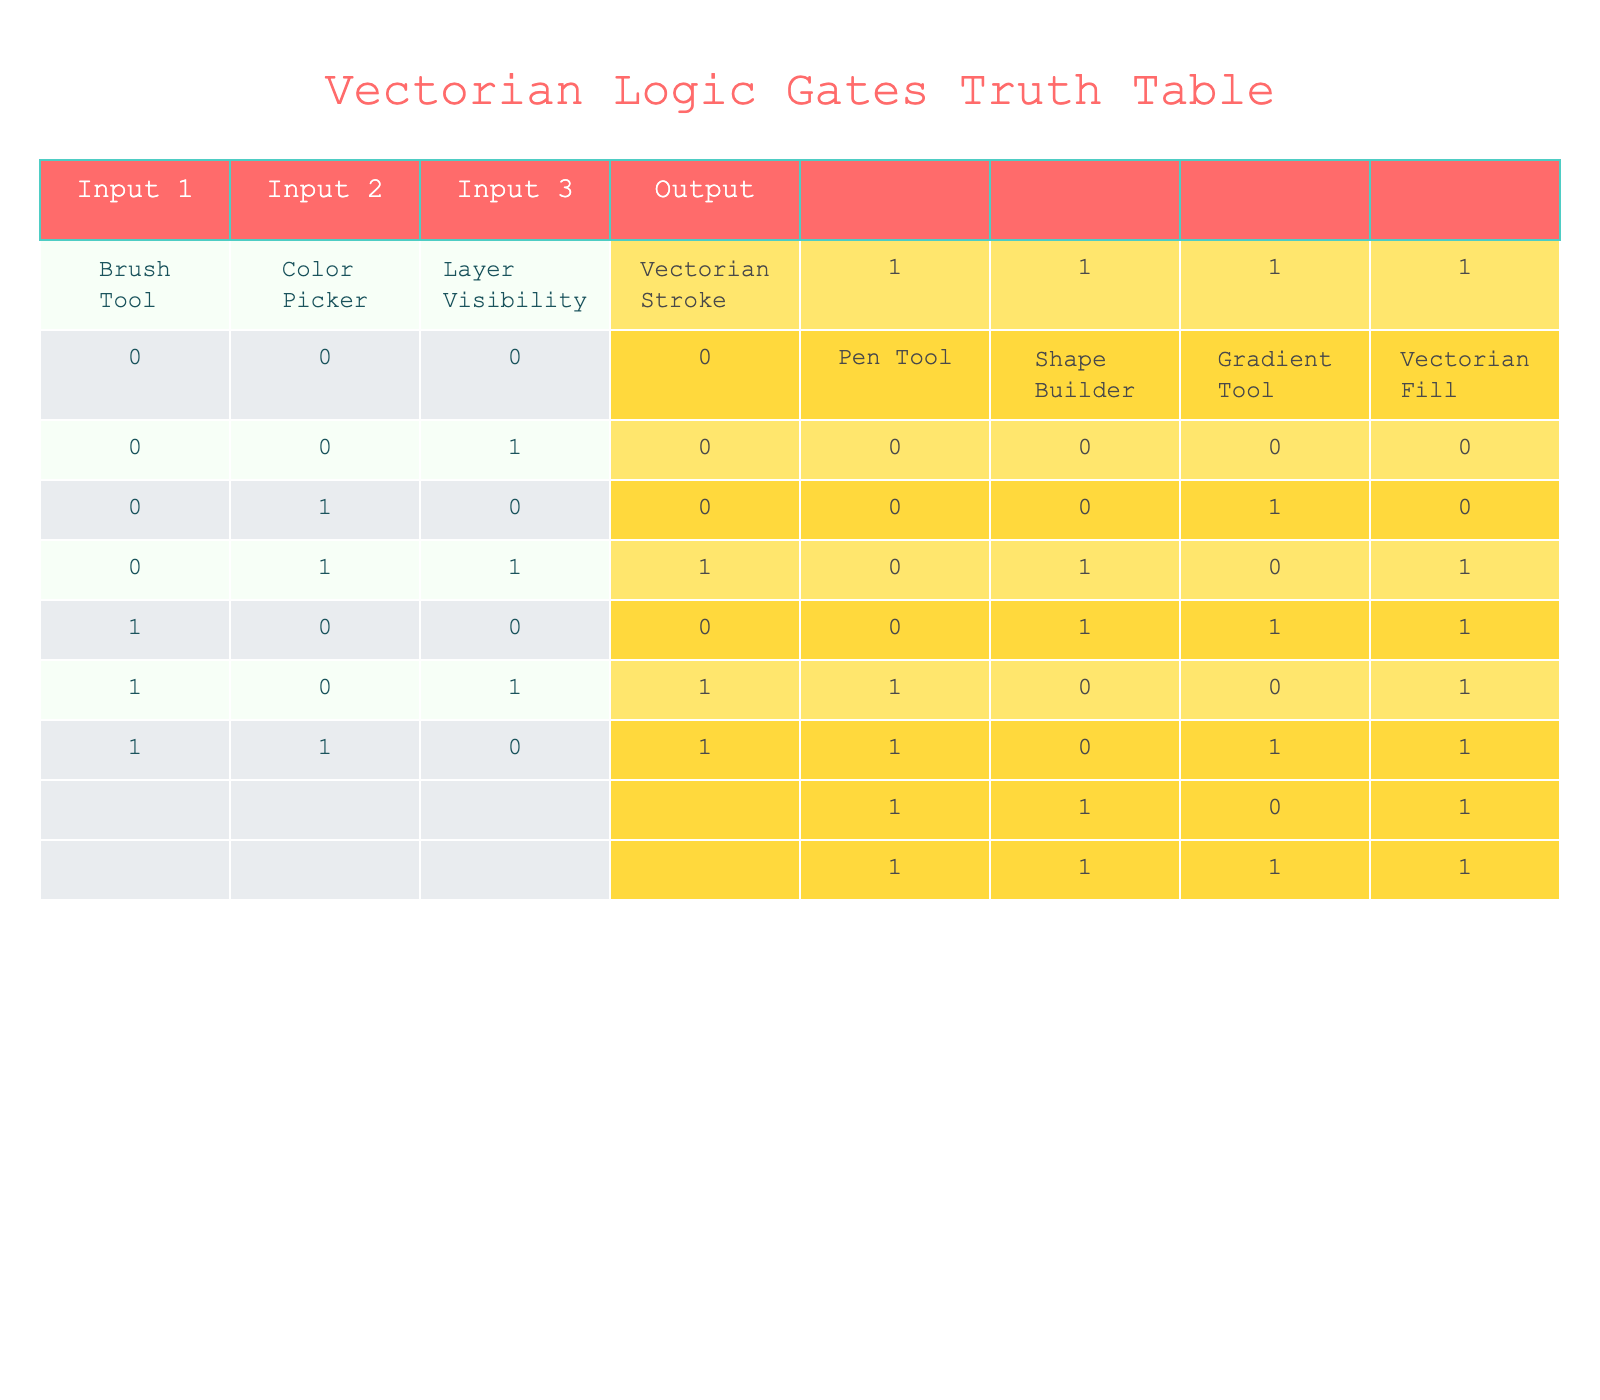What is the output when the Brush Tool and Color Picker are both off? According to the table, when both the Brush Tool (0) and Color Picker (0) are off, the output is 0, indicating no Vectorian Stroke is produced.
Answer: 0 What happens to the output if the Pen Tool is on while the Shape Builder and Gradient Tool are both off? In the table, when the Pen Tool is on (1) and the Shape Builder and Gradient Tool are both off (0, 0), the output for Vectorian Fill is 1.
Answer: 1 How many combinations of inputs result in a Vectorian Stroke output of 1? The table indicates that there are 4 combinations of inputs that result in a Vectorian Stroke output of 1: (0, 1, 1), (1, 0, 1), (1, 1, 0), and (1, 1, 1). By counting these combinations, we find there are 4.
Answer: 4 Is there any situation where both outputs (Vectorian Stroke and Vectorian Fill) are 0? Yes, the table shows that when all inputs are off (0, 0, 0 for both sets), both outputs are indeed 0, confirming that this situation exists.
Answer: Yes If the Shape Builder is on, what are the possible outputs for Vectorian Fill based on the other inputs? When the Shape Builder is on, the output for Vectorian Fill is determined by the state of the Pen Tool and the Gradient Tool. From the table: - (0, 1, 0) => output 1 - (0, 1, 1) => output 1 - (1, 1, 0) => output 1 - (1, 1, 1) => output 1. Therefore, the possible output is always 1 when the Shape Builder is on.
Answer: 1 What is the output of Vectorian Stroke when both the Brush Tool and Layer Visibility are on? From the table, with the Brush Tool on (1) and Layer Visibility also on (1), the output for Vectorian Stroke is 1, regardless of the state of the Color Picker.
Answer: 1 